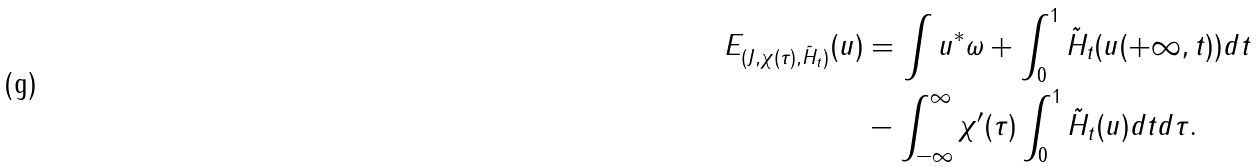<formula> <loc_0><loc_0><loc_500><loc_500>E _ { ( J , \chi ( \tau ) , \tilde { H } _ { t } ) } ( u ) & = \int u ^ { * } \omega + \int _ { 0 } ^ { 1 } \tilde { H } _ { t } ( u ( + \infty , t ) ) d t \\ & - \int _ { - \infty } ^ { \infty } \chi ^ { \prime } ( \tau ) \int _ { 0 } ^ { 1 } \tilde { H } _ { t } ( u ) d t d \tau .</formula> 